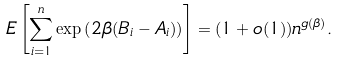<formula> <loc_0><loc_0><loc_500><loc_500>E \left [ \sum _ { i = 1 } ^ { n } \exp \left ( 2 \beta ( B _ { i } - A _ { i } ) \right ) \right ] = ( 1 + o ( 1 ) ) n ^ { g ( \beta ) } .</formula> 